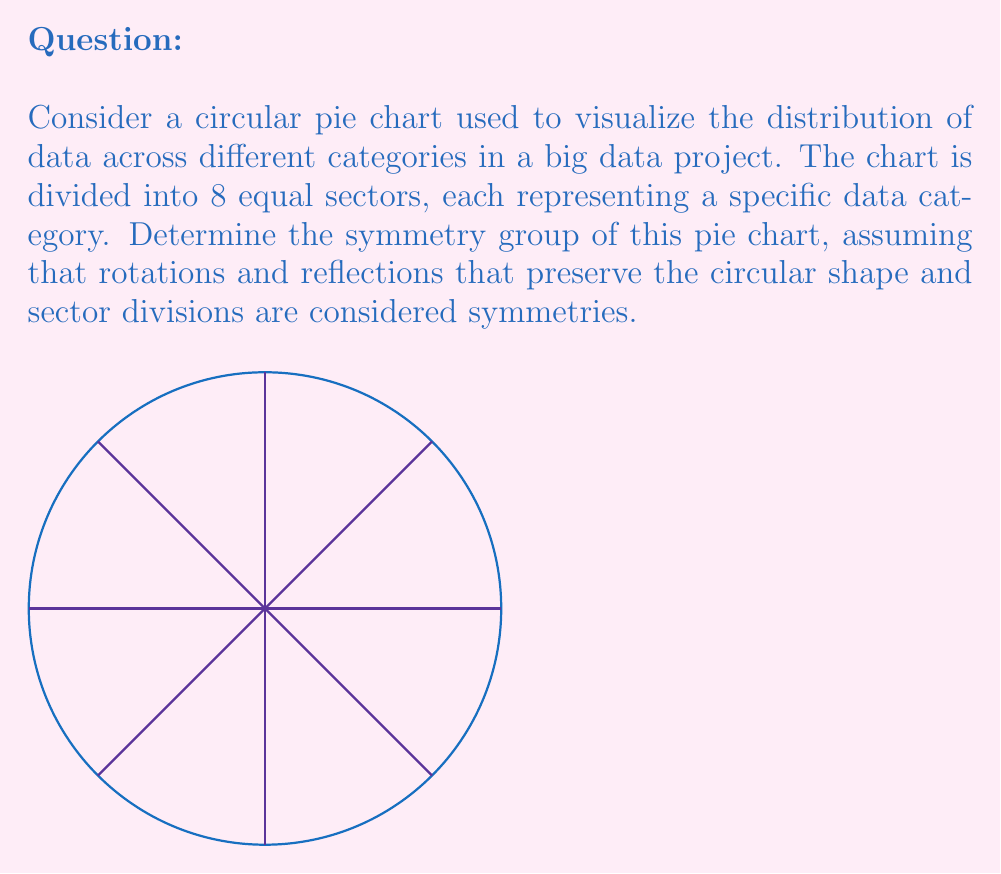Show me your answer to this math problem. To determine the symmetry group of the pie chart, we need to identify all the symmetries that preserve its structure:

1. Rotational symmetries:
   - The chart can be rotated by multiples of 45° (360°/8) and remain unchanged.
   - There are 8 rotational symmetries: 0°, 45°, 90°, 135°, 180°, 225°, 270°, 315°.

2. Reflection symmetries:
   - There are 8 lines of reflection: 4 passing through opposite vertices and 4 passing through the midpoints of opposite sides.

3. Identity symmetry:
   - The identity transformation (do nothing) is always a symmetry.

The total number of symmetries is 8 (rotations) + 8 (reflections) + 1 (identity) = 17.

This group of symmetries is isomorphic to the dihedral group $D_8$, which is the symmetry group of a regular octagon. The group has the following properties:

- Order of the group: $|D_8| = 16 + 1 = 17$
- Generators: $r$ (rotation by 45°) and $s$ (reflection across a vertical axis)
- Presentation: $D_8 = \langle r, s \mid r^8 = s^2 = 1, srs = r^{-1} \rangle$

The elements of the group can be written as:
$$D_8 = \{1, r, r^2, r^3, r^4, r^5, r^6, r^7, s, sr, sr^2, sr^3, sr^4, sr^5, sr^6, sr^7\}$$

This group structure captures all the symmetries of the pie chart, allowing for a mathematical representation of its visual properties.
Answer: $D_8$ (Dihedral group of order 16) 